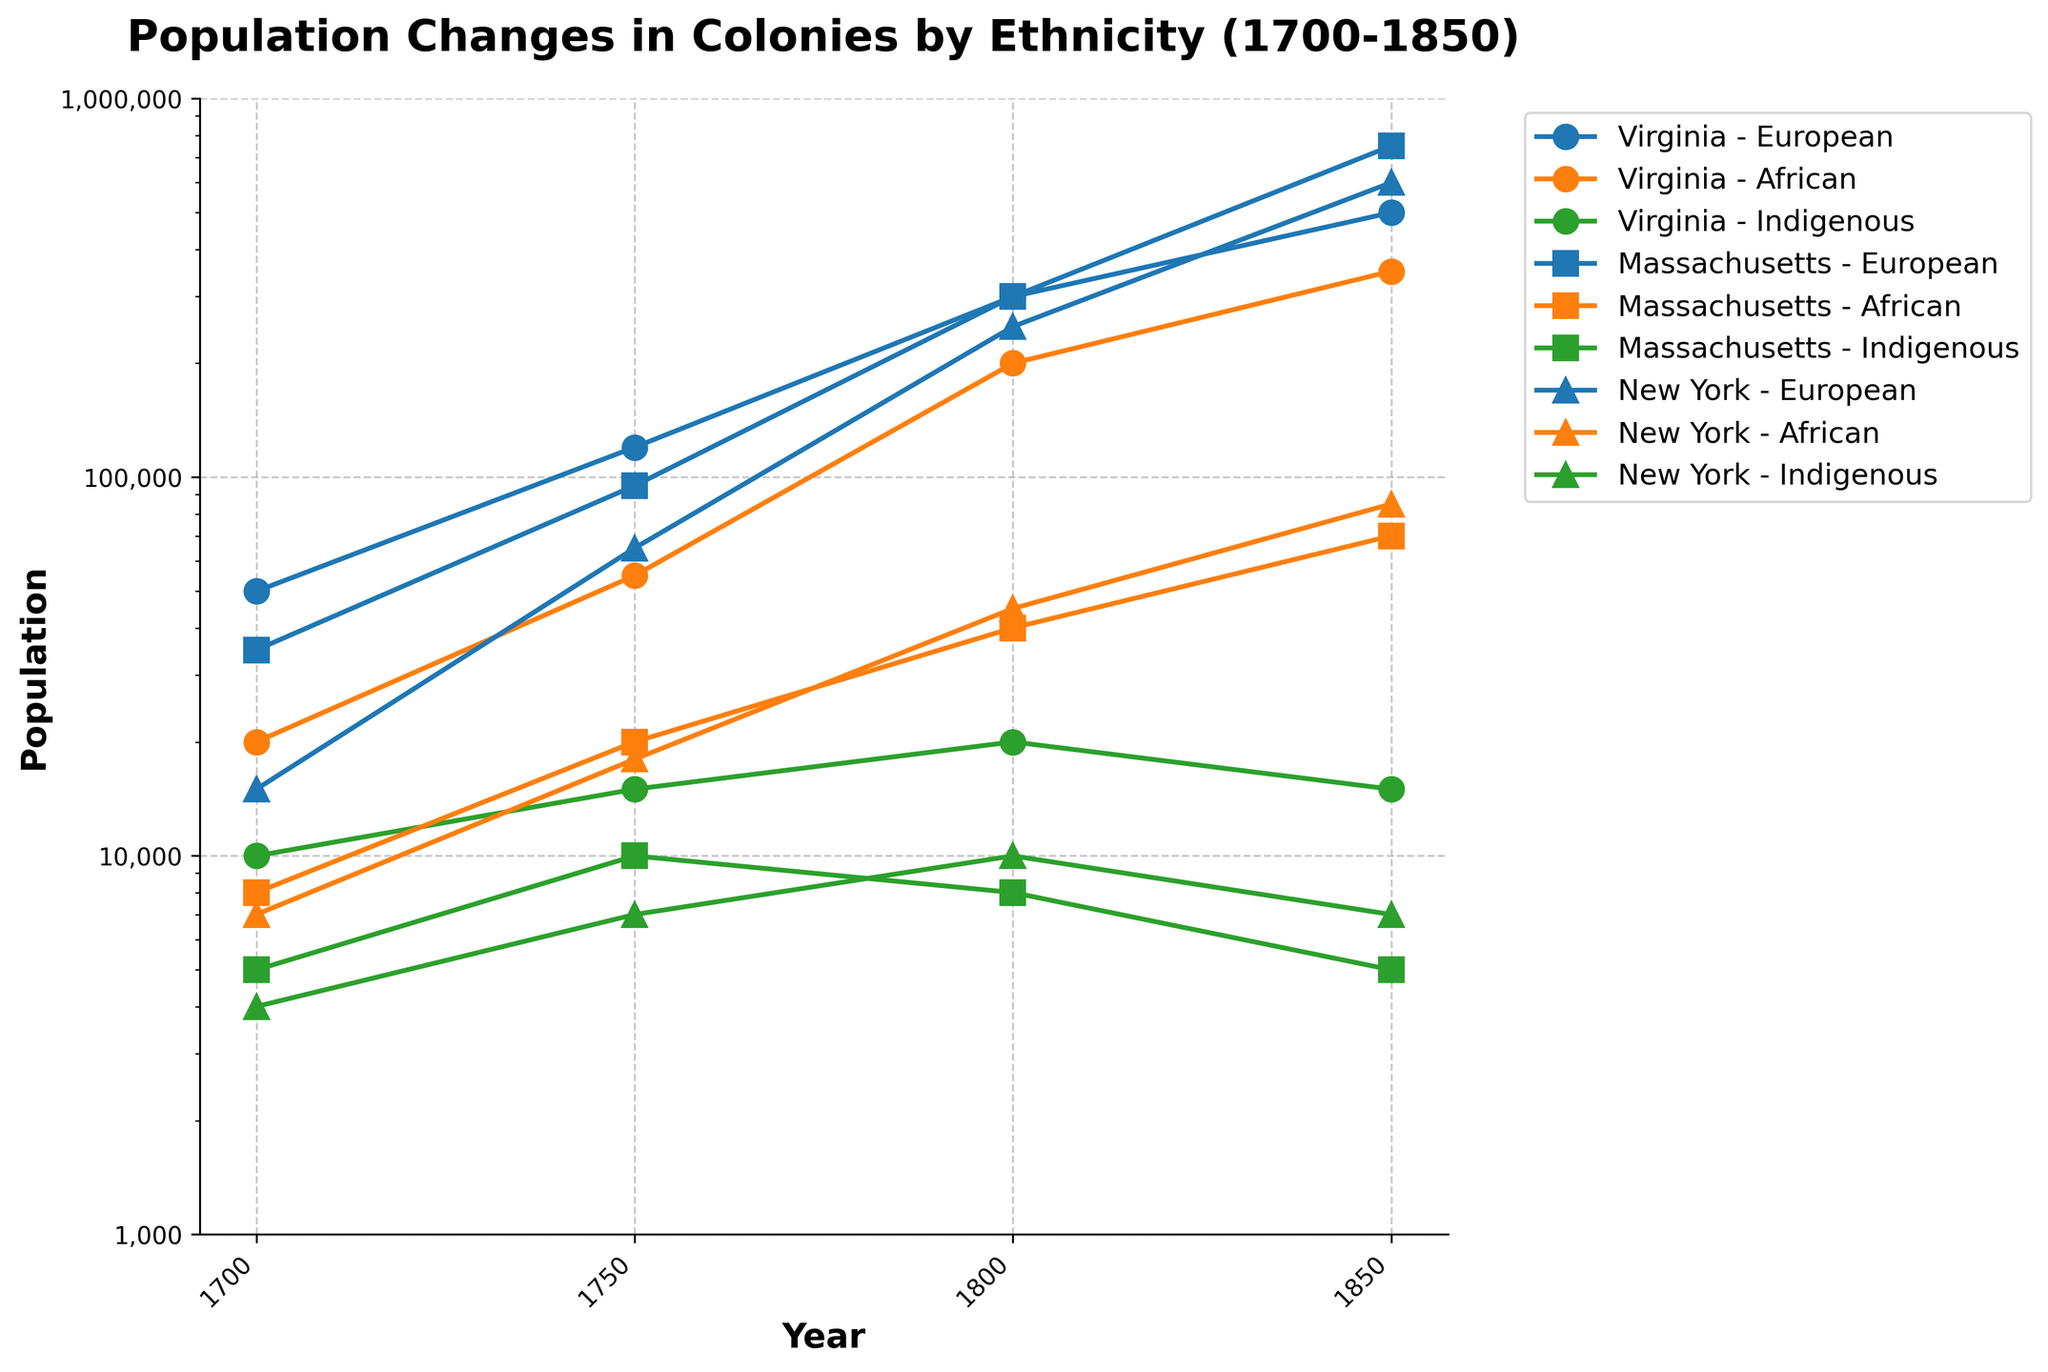What is the title of the figure? The title is usually placed at the top of the figure. It reads 'Population Changes in Colonies by Ethnicity (1700-1850).'
Answer: Population Changes in Colonies by Ethnicity (1700-1850) How many unique years are displayed on the x-axis? The x-axis shows tick marks corresponding to the years and labels that are rotated for visibility. By counting them, we see the years are 1700, 1750, 1800, and 1850.
Answer: 4 Which colony had the largest European population in 1850? By tracing the lines representing European populations to 1850, we see that Massachusetts had the highest value.
Answer: Massachusetts Between 1700 and 1750, which ethnic group in Virginia saw the largest increase in population? By comparing the population markers at 1700 and 1750 for each ethnic group in Virginia, we see Europeans increased from 50,000 to 120,000, Africans from 20,000 to 55,000, and Indigenous from 10,000 to 15,000. The Europeans saw the largest numeric increase.
Answer: European What was the combined population of Indigenous people in all colonies in 1800? Sum the Indigenous population in Virginia (20,000), Massachusetts (8,000), and New York (10,000) at the year 1800. Thus, 20,000 + 8,000 + 10,000 = 38,000.
Answer: 38,000 Compare the population trends of Europeans in New York and Virginia from 1700 to 1850. Which colony's European population grew faster? By examining the plot lines for European populations: New York grew from 15,000 in 1700 to 600,000 in 1850, while Virginia grew from 50,000 to 500,000. The percentage increase for New York (by a factor of 40) is greater than Virginia (by a factor of 10).
Answer: New York In 1750, which ethnic group had the smallest population in Massachusetts? By inspecting the plot markers for Massachusetts in 1750, the Indigenous population was 10,000, smaller than both Europeans (95,000) and Africans (20,000).
Answer: Indigenous What is the percentage change in the African population in New York from 1750 to 1800? African population in New York was 18,000 in 1750 and 45,000 in 1800. The percentage change is ((45,000 - 18,000) / 18,000) * 100 = 150%.
Answer: 150% Which ethnic group in Virginia had the least change in population from 1800 to 1850? Evaluate the differences for each ethnic group in Virginia: Europeans (500,000 - 300,000 = 200,000), Africans (350,000 - 200,000 = 150,000), Indigenous (15,000 - 20,000 = -5,000). The Indigenous population had the smallest absolute change.
Answer: Indigenous 